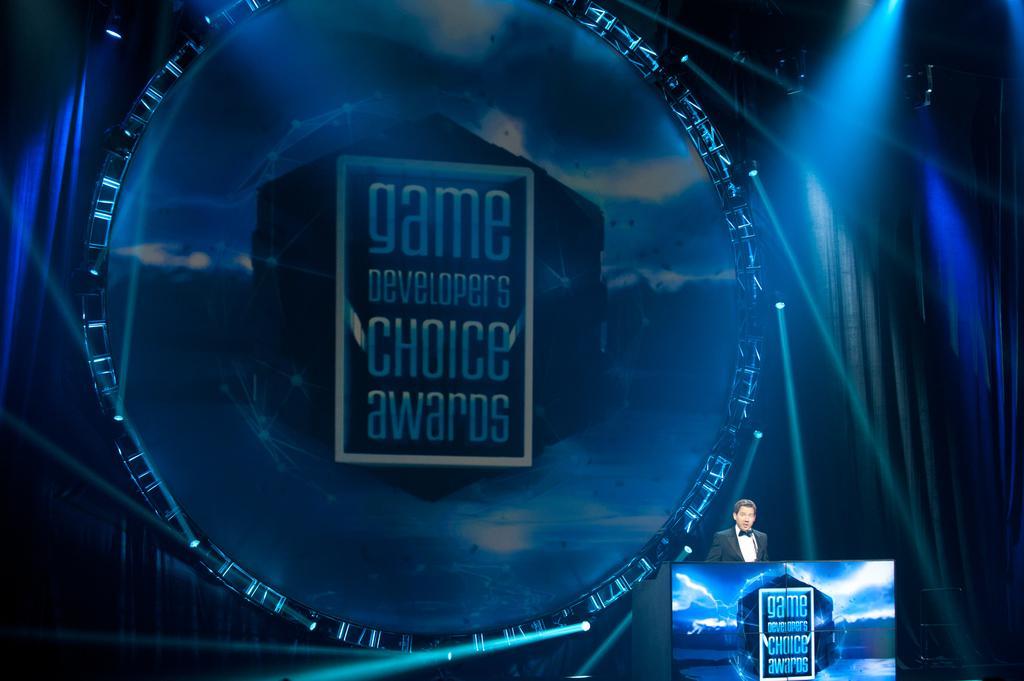Can you describe this image briefly? In this image I see a man who is wearing a suit and I see that he is standing in front of a podium and I see something is written over here. In the background I see the lights and the curtains and I see something is written over here too. 